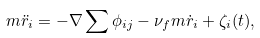<formula> <loc_0><loc_0><loc_500><loc_500>m \ddot { r } _ { i } = - \nabla \sum \phi _ { i j } - \nu _ { f } m \dot { r } _ { i } + \zeta _ { i } ( t ) ,</formula> 